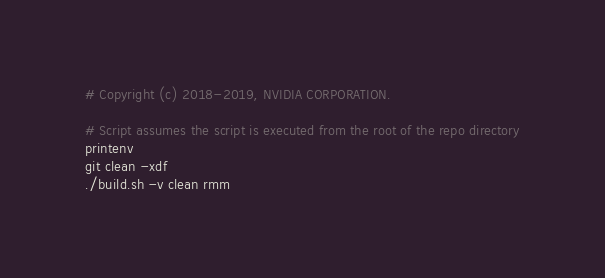Convert code to text. <code><loc_0><loc_0><loc_500><loc_500><_Bash_># Copyright (c) 2018-2019, NVIDIA CORPORATION.

# Script assumes the script is executed from the root of the repo directory
printenv
git clean -xdf
./build.sh -v clean rmm
</code> 